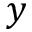<formula> <loc_0><loc_0><loc_500><loc_500>y</formula> 